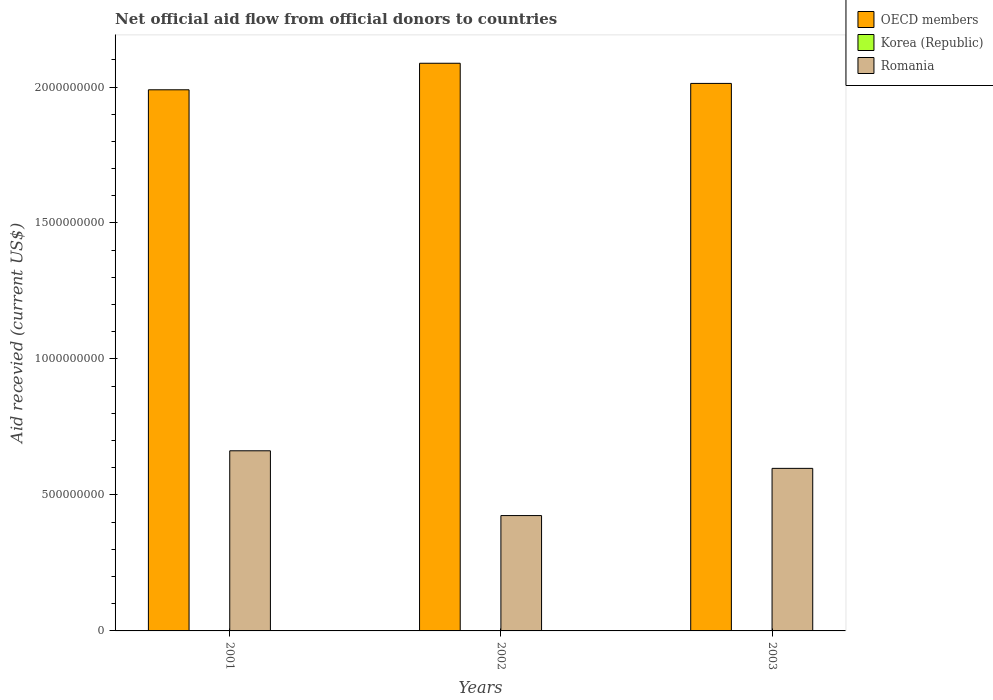How many different coloured bars are there?
Keep it short and to the point. 2. Are the number of bars per tick equal to the number of legend labels?
Give a very brief answer. No. How many bars are there on the 1st tick from the left?
Make the answer very short. 2. What is the label of the 3rd group of bars from the left?
Ensure brevity in your answer.  2003. In how many cases, is the number of bars for a given year not equal to the number of legend labels?
Your response must be concise. 3. What is the total aid received in Korea (Republic) in 2003?
Keep it short and to the point. 0. Across all years, what is the maximum total aid received in Romania?
Ensure brevity in your answer.  6.62e+08. What is the total total aid received in Korea (Republic) in the graph?
Give a very brief answer. 0. What is the difference between the total aid received in OECD members in 2002 and that in 2003?
Your answer should be compact. 7.41e+07. What is the difference between the total aid received in Korea (Republic) in 2003 and the total aid received in Romania in 2002?
Your response must be concise. -4.24e+08. What is the average total aid received in OECD members per year?
Make the answer very short. 2.03e+09. In the year 2001, what is the difference between the total aid received in Romania and total aid received in OECD members?
Offer a very short reply. -1.33e+09. In how many years, is the total aid received in OECD members greater than 1200000000 US$?
Provide a succinct answer. 3. What is the ratio of the total aid received in OECD members in 2001 to that in 2002?
Make the answer very short. 0.95. Is the total aid received in OECD members in 2001 less than that in 2002?
Provide a short and direct response. Yes. Is the difference between the total aid received in Romania in 2001 and 2003 greater than the difference between the total aid received in OECD members in 2001 and 2003?
Offer a very short reply. Yes. What is the difference between the highest and the second highest total aid received in OECD members?
Keep it short and to the point. 7.41e+07. What is the difference between the highest and the lowest total aid received in OECD members?
Give a very brief answer. 9.76e+07. In how many years, is the total aid received in Romania greater than the average total aid received in Romania taken over all years?
Give a very brief answer. 2. Is the sum of the total aid received in OECD members in 2001 and 2003 greater than the maximum total aid received in Romania across all years?
Your answer should be very brief. Yes. Is it the case that in every year, the sum of the total aid received in OECD members and total aid received in Korea (Republic) is greater than the total aid received in Romania?
Keep it short and to the point. Yes. Are all the bars in the graph horizontal?
Provide a short and direct response. No. How many years are there in the graph?
Your response must be concise. 3. Are the values on the major ticks of Y-axis written in scientific E-notation?
Make the answer very short. No. Does the graph contain any zero values?
Offer a terse response. Yes. Where does the legend appear in the graph?
Your response must be concise. Top right. What is the title of the graph?
Your response must be concise. Net official aid flow from official donors to countries. Does "Ireland" appear as one of the legend labels in the graph?
Make the answer very short. No. What is the label or title of the X-axis?
Offer a terse response. Years. What is the label or title of the Y-axis?
Offer a terse response. Aid recevied (current US$). What is the Aid recevied (current US$) of OECD members in 2001?
Offer a terse response. 1.99e+09. What is the Aid recevied (current US$) in Romania in 2001?
Provide a succinct answer. 6.62e+08. What is the Aid recevied (current US$) in OECD members in 2002?
Keep it short and to the point. 2.09e+09. What is the Aid recevied (current US$) in Romania in 2002?
Give a very brief answer. 4.24e+08. What is the Aid recevied (current US$) of OECD members in 2003?
Offer a very short reply. 2.01e+09. What is the Aid recevied (current US$) of Korea (Republic) in 2003?
Make the answer very short. 0. What is the Aid recevied (current US$) in Romania in 2003?
Make the answer very short. 5.98e+08. Across all years, what is the maximum Aid recevied (current US$) of OECD members?
Offer a very short reply. 2.09e+09. Across all years, what is the maximum Aid recevied (current US$) of Romania?
Make the answer very short. 6.62e+08. Across all years, what is the minimum Aid recevied (current US$) in OECD members?
Make the answer very short. 1.99e+09. Across all years, what is the minimum Aid recevied (current US$) in Romania?
Give a very brief answer. 4.24e+08. What is the total Aid recevied (current US$) in OECD members in the graph?
Give a very brief answer. 6.09e+09. What is the total Aid recevied (current US$) in Romania in the graph?
Provide a succinct answer. 1.68e+09. What is the difference between the Aid recevied (current US$) of OECD members in 2001 and that in 2002?
Ensure brevity in your answer.  -9.76e+07. What is the difference between the Aid recevied (current US$) in Romania in 2001 and that in 2002?
Ensure brevity in your answer.  2.38e+08. What is the difference between the Aid recevied (current US$) of OECD members in 2001 and that in 2003?
Keep it short and to the point. -2.34e+07. What is the difference between the Aid recevied (current US$) in Romania in 2001 and that in 2003?
Your answer should be very brief. 6.46e+07. What is the difference between the Aid recevied (current US$) of OECD members in 2002 and that in 2003?
Make the answer very short. 7.41e+07. What is the difference between the Aid recevied (current US$) in Romania in 2002 and that in 2003?
Provide a short and direct response. -1.74e+08. What is the difference between the Aid recevied (current US$) in OECD members in 2001 and the Aid recevied (current US$) in Romania in 2002?
Make the answer very short. 1.57e+09. What is the difference between the Aid recevied (current US$) in OECD members in 2001 and the Aid recevied (current US$) in Romania in 2003?
Make the answer very short. 1.39e+09. What is the difference between the Aid recevied (current US$) in OECD members in 2002 and the Aid recevied (current US$) in Romania in 2003?
Provide a succinct answer. 1.49e+09. What is the average Aid recevied (current US$) in OECD members per year?
Offer a very short reply. 2.03e+09. What is the average Aid recevied (current US$) in Romania per year?
Your response must be concise. 5.61e+08. In the year 2001, what is the difference between the Aid recevied (current US$) of OECD members and Aid recevied (current US$) of Romania?
Provide a succinct answer. 1.33e+09. In the year 2002, what is the difference between the Aid recevied (current US$) of OECD members and Aid recevied (current US$) of Romania?
Provide a succinct answer. 1.66e+09. In the year 2003, what is the difference between the Aid recevied (current US$) of OECD members and Aid recevied (current US$) of Romania?
Keep it short and to the point. 1.42e+09. What is the ratio of the Aid recevied (current US$) of OECD members in 2001 to that in 2002?
Offer a terse response. 0.95. What is the ratio of the Aid recevied (current US$) of Romania in 2001 to that in 2002?
Your answer should be compact. 1.56. What is the ratio of the Aid recevied (current US$) of OECD members in 2001 to that in 2003?
Offer a terse response. 0.99. What is the ratio of the Aid recevied (current US$) of Romania in 2001 to that in 2003?
Provide a short and direct response. 1.11. What is the ratio of the Aid recevied (current US$) of OECD members in 2002 to that in 2003?
Ensure brevity in your answer.  1.04. What is the ratio of the Aid recevied (current US$) in Romania in 2002 to that in 2003?
Offer a very short reply. 0.71. What is the difference between the highest and the second highest Aid recevied (current US$) of OECD members?
Offer a very short reply. 7.41e+07. What is the difference between the highest and the second highest Aid recevied (current US$) in Romania?
Make the answer very short. 6.46e+07. What is the difference between the highest and the lowest Aid recevied (current US$) in OECD members?
Offer a very short reply. 9.76e+07. What is the difference between the highest and the lowest Aid recevied (current US$) of Romania?
Give a very brief answer. 2.38e+08. 